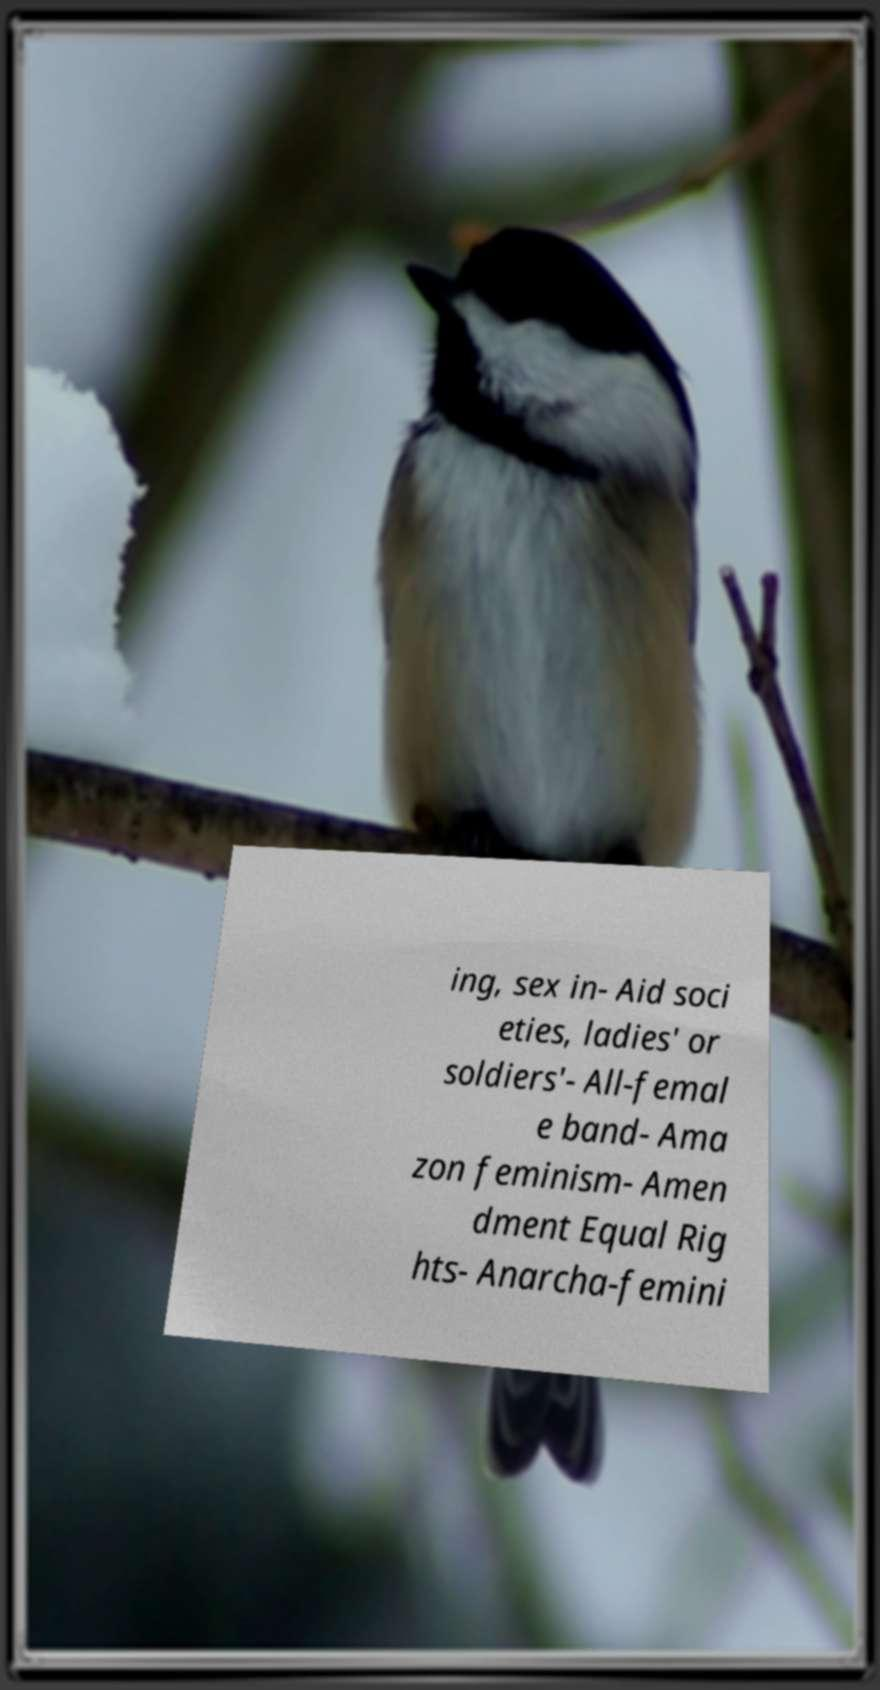I need the written content from this picture converted into text. Can you do that? ing, sex in- Aid soci eties, ladies' or soldiers'- All-femal e band- Ama zon feminism- Amen dment Equal Rig hts- Anarcha-femini 